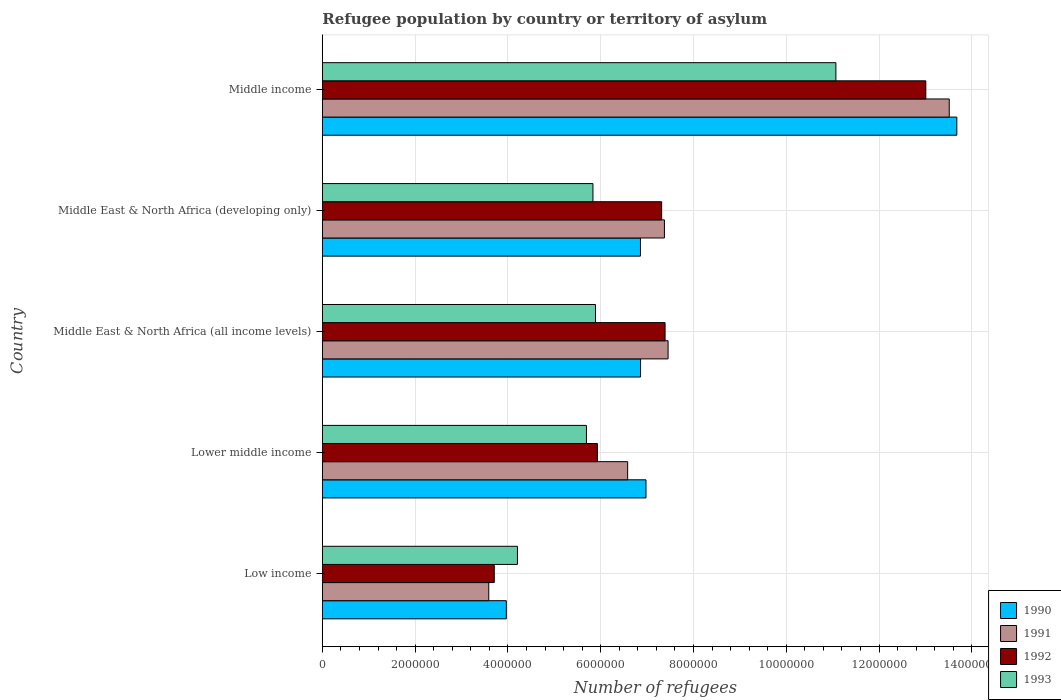How many different coloured bars are there?
Give a very brief answer. 4. How many groups of bars are there?
Keep it short and to the point. 5. Are the number of bars on each tick of the Y-axis equal?
Provide a succinct answer. Yes. How many bars are there on the 2nd tick from the top?
Give a very brief answer. 4. What is the label of the 5th group of bars from the top?
Offer a very short reply. Low income. In how many cases, is the number of bars for a given country not equal to the number of legend labels?
Provide a short and direct response. 0. What is the number of refugees in 1991 in Middle East & North Africa (developing only)?
Keep it short and to the point. 7.37e+06. Across all countries, what is the maximum number of refugees in 1993?
Your response must be concise. 1.11e+07. Across all countries, what is the minimum number of refugees in 1991?
Ensure brevity in your answer.  3.59e+06. What is the total number of refugees in 1990 in the graph?
Give a very brief answer. 3.83e+07. What is the difference between the number of refugees in 1991 in Middle East & North Africa (all income levels) and that in Middle income?
Provide a succinct answer. -6.06e+06. What is the difference between the number of refugees in 1992 in Middle East & North Africa (all income levels) and the number of refugees in 1991 in Lower middle income?
Offer a very short reply. 8.06e+05. What is the average number of refugees in 1991 per country?
Offer a very short reply. 7.70e+06. What is the difference between the number of refugees in 1990 and number of refugees in 1992 in Low income?
Your answer should be very brief. 2.60e+05. In how many countries, is the number of refugees in 1990 greater than 7600000 ?
Provide a succinct answer. 1. What is the ratio of the number of refugees in 1991 in Lower middle income to that in Middle East & North Africa (all income levels)?
Provide a succinct answer. 0.88. Is the difference between the number of refugees in 1990 in Low income and Middle income greater than the difference between the number of refugees in 1992 in Low income and Middle income?
Offer a very short reply. No. What is the difference between the highest and the second highest number of refugees in 1991?
Keep it short and to the point. 6.06e+06. What is the difference between the highest and the lowest number of refugees in 1991?
Offer a very short reply. 9.92e+06. Is the sum of the number of refugees in 1990 in Low income and Middle East & North Africa (developing only) greater than the maximum number of refugees in 1992 across all countries?
Offer a very short reply. No. What does the 4th bar from the bottom in Low income represents?
Provide a short and direct response. 1993. Is it the case that in every country, the sum of the number of refugees in 1993 and number of refugees in 1990 is greater than the number of refugees in 1992?
Provide a succinct answer. Yes. What is the difference between two consecutive major ticks on the X-axis?
Provide a short and direct response. 2.00e+06. Does the graph contain grids?
Offer a terse response. Yes. Where does the legend appear in the graph?
Your answer should be very brief. Bottom right. How are the legend labels stacked?
Give a very brief answer. Vertical. What is the title of the graph?
Keep it short and to the point. Refugee population by country or territory of asylum. Does "1987" appear as one of the legend labels in the graph?
Your answer should be very brief. No. What is the label or title of the X-axis?
Provide a short and direct response. Number of refugees. What is the Number of refugees of 1990 in Low income?
Ensure brevity in your answer.  3.97e+06. What is the Number of refugees in 1991 in Low income?
Ensure brevity in your answer.  3.59e+06. What is the Number of refugees of 1992 in Low income?
Offer a very short reply. 3.71e+06. What is the Number of refugees in 1993 in Low income?
Offer a terse response. 4.21e+06. What is the Number of refugees of 1990 in Lower middle income?
Keep it short and to the point. 6.98e+06. What is the Number of refugees of 1991 in Lower middle income?
Give a very brief answer. 6.58e+06. What is the Number of refugees in 1992 in Lower middle income?
Your answer should be compact. 5.93e+06. What is the Number of refugees in 1993 in Lower middle income?
Make the answer very short. 5.69e+06. What is the Number of refugees of 1990 in Middle East & North Africa (all income levels)?
Offer a terse response. 6.86e+06. What is the Number of refugees in 1991 in Middle East & North Africa (all income levels)?
Offer a terse response. 7.45e+06. What is the Number of refugees of 1992 in Middle East & North Africa (all income levels)?
Keep it short and to the point. 7.39e+06. What is the Number of refugees of 1993 in Middle East & North Africa (all income levels)?
Provide a succinct answer. 5.89e+06. What is the Number of refugees in 1990 in Middle East & North Africa (developing only)?
Provide a short and direct response. 6.86e+06. What is the Number of refugees in 1991 in Middle East & North Africa (developing only)?
Make the answer very short. 7.37e+06. What is the Number of refugees in 1992 in Middle East & North Africa (developing only)?
Your answer should be very brief. 7.31e+06. What is the Number of refugees in 1993 in Middle East & North Africa (developing only)?
Your answer should be very brief. 5.83e+06. What is the Number of refugees of 1990 in Middle income?
Ensure brevity in your answer.  1.37e+07. What is the Number of refugees of 1991 in Middle income?
Offer a terse response. 1.35e+07. What is the Number of refugees of 1992 in Middle income?
Ensure brevity in your answer.  1.30e+07. What is the Number of refugees of 1993 in Middle income?
Offer a very short reply. 1.11e+07. Across all countries, what is the maximum Number of refugees of 1990?
Your response must be concise. 1.37e+07. Across all countries, what is the maximum Number of refugees of 1991?
Ensure brevity in your answer.  1.35e+07. Across all countries, what is the maximum Number of refugees in 1992?
Offer a terse response. 1.30e+07. Across all countries, what is the maximum Number of refugees of 1993?
Your answer should be compact. 1.11e+07. Across all countries, what is the minimum Number of refugees of 1990?
Keep it short and to the point. 3.97e+06. Across all countries, what is the minimum Number of refugees in 1991?
Offer a very short reply. 3.59e+06. Across all countries, what is the minimum Number of refugees in 1992?
Ensure brevity in your answer.  3.71e+06. Across all countries, what is the minimum Number of refugees of 1993?
Provide a short and direct response. 4.21e+06. What is the total Number of refugees of 1990 in the graph?
Offer a terse response. 3.83e+07. What is the total Number of refugees of 1991 in the graph?
Keep it short and to the point. 3.85e+07. What is the total Number of refugees in 1992 in the graph?
Give a very brief answer. 3.73e+07. What is the total Number of refugees in 1993 in the graph?
Offer a very short reply. 3.27e+07. What is the difference between the Number of refugees in 1990 in Low income and that in Lower middle income?
Your answer should be compact. -3.01e+06. What is the difference between the Number of refugees in 1991 in Low income and that in Lower middle income?
Your response must be concise. -2.99e+06. What is the difference between the Number of refugees in 1992 in Low income and that in Lower middle income?
Make the answer very short. -2.22e+06. What is the difference between the Number of refugees of 1993 in Low income and that in Lower middle income?
Provide a succinct answer. -1.49e+06. What is the difference between the Number of refugees of 1990 in Low income and that in Middle East & North Africa (all income levels)?
Offer a very short reply. -2.89e+06. What is the difference between the Number of refugees in 1991 in Low income and that in Middle East & North Africa (all income levels)?
Make the answer very short. -3.86e+06. What is the difference between the Number of refugees of 1992 in Low income and that in Middle East & North Africa (all income levels)?
Ensure brevity in your answer.  -3.68e+06. What is the difference between the Number of refugees in 1993 in Low income and that in Middle East & North Africa (all income levels)?
Your answer should be very brief. -1.68e+06. What is the difference between the Number of refugees in 1990 in Low income and that in Middle East & North Africa (developing only)?
Offer a very short reply. -2.89e+06. What is the difference between the Number of refugees in 1991 in Low income and that in Middle East & North Africa (developing only)?
Keep it short and to the point. -3.79e+06. What is the difference between the Number of refugees in 1992 in Low income and that in Middle East & North Africa (developing only)?
Your answer should be compact. -3.61e+06. What is the difference between the Number of refugees in 1993 in Low income and that in Middle East & North Africa (developing only)?
Make the answer very short. -1.63e+06. What is the difference between the Number of refugees of 1990 in Low income and that in Middle income?
Make the answer very short. -9.71e+06. What is the difference between the Number of refugees in 1991 in Low income and that in Middle income?
Keep it short and to the point. -9.92e+06. What is the difference between the Number of refugees of 1992 in Low income and that in Middle income?
Make the answer very short. -9.30e+06. What is the difference between the Number of refugees in 1993 in Low income and that in Middle income?
Offer a terse response. -6.86e+06. What is the difference between the Number of refugees of 1990 in Lower middle income and that in Middle East & North Africa (all income levels)?
Provide a short and direct response. 1.17e+05. What is the difference between the Number of refugees of 1991 in Lower middle income and that in Middle East & North Africa (all income levels)?
Provide a short and direct response. -8.71e+05. What is the difference between the Number of refugees of 1992 in Lower middle income and that in Middle East & North Africa (all income levels)?
Your answer should be compact. -1.46e+06. What is the difference between the Number of refugees in 1993 in Lower middle income and that in Middle East & North Africa (all income levels)?
Keep it short and to the point. -1.95e+05. What is the difference between the Number of refugees of 1990 in Lower middle income and that in Middle East & North Africa (developing only)?
Your answer should be compact. 1.19e+05. What is the difference between the Number of refugees in 1991 in Lower middle income and that in Middle East & North Africa (developing only)?
Make the answer very short. -7.92e+05. What is the difference between the Number of refugees in 1992 in Lower middle income and that in Middle East & North Africa (developing only)?
Keep it short and to the point. -1.39e+06. What is the difference between the Number of refugees of 1993 in Lower middle income and that in Middle East & North Africa (developing only)?
Your answer should be compact. -1.40e+05. What is the difference between the Number of refugees of 1990 in Lower middle income and that in Middle income?
Provide a succinct answer. -6.70e+06. What is the difference between the Number of refugees of 1991 in Lower middle income and that in Middle income?
Your answer should be compact. -6.93e+06. What is the difference between the Number of refugees of 1992 in Lower middle income and that in Middle income?
Your response must be concise. -7.08e+06. What is the difference between the Number of refugees of 1993 in Lower middle income and that in Middle income?
Provide a succinct answer. -5.38e+06. What is the difference between the Number of refugees in 1990 in Middle East & North Africa (all income levels) and that in Middle East & North Africa (developing only)?
Offer a terse response. 1780. What is the difference between the Number of refugees in 1991 in Middle East & North Africa (all income levels) and that in Middle East & North Africa (developing only)?
Make the answer very short. 7.89e+04. What is the difference between the Number of refugees of 1992 in Middle East & North Africa (all income levels) and that in Middle East & North Africa (developing only)?
Provide a short and direct response. 7.35e+04. What is the difference between the Number of refugees in 1993 in Middle East & North Africa (all income levels) and that in Middle East & North Africa (developing only)?
Provide a succinct answer. 5.50e+04. What is the difference between the Number of refugees in 1990 in Middle East & North Africa (all income levels) and that in Middle income?
Your answer should be compact. -6.82e+06. What is the difference between the Number of refugees in 1991 in Middle East & North Africa (all income levels) and that in Middle income?
Your answer should be very brief. -6.06e+06. What is the difference between the Number of refugees in 1992 in Middle East & North Africa (all income levels) and that in Middle income?
Give a very brief answer. -5.62e+06. What is the difference between the Number of refugees in 1993 in Middle East & North Africa (all income levels) and that in Middle income?
Offer a terse response. -5.18e+06. What is the difference between the Number of refugees of 1990 in Middle East & North Africa (developing only) and that in Middle income?
Give a very brief answer. -6.82e+06. What is the difference between the Number of refugees in 1991 in Middle East & North Africa (developing only) and that in Middle income?
Your answer should be very brief. -6.14e+06. What is the difference between the Number of refugees of 1992 in Middle East & North Africa (developing only) and that in Middle income?
Offer a very short reply. -5.69e+06. What is the difference between the Number of refugees of 1993 in Middle East & North Africa (developing only) and that in Middle income?
Provide a short and direct response. -5.24e+06. What is the difference between the Number of refugees in 1990 in Low income and the Number of refugees in 1991 in Lower middle income?
Your answer should be compact. -2.62e+06. What is the difference between the Number of refugees of 1990 in Low income and the Number of refugees of 1992 in Lower middle income?
Offer a terse response. -1.96e+06. What is the difference between the Number of refugees in 1990 in Low income and the Number of refugees in 1993 in Lower middle income?
Provide a short and direct response. -1.73e+06. What is the difference between the Number of refugees in 1991 in Low income and the Number of refugees in 1992 in Lower middle income?
Keep it short and to the point. -2.34e+06. What is the difference between the Number of refugees in 1991 in Low income and the Number of refugees in 1993 in Lower middle income?
Make the answer very short. -2.11e+06. What is the difference between the Number of refugees in 1992 in Low income and the Number of refugees in 1993 in Lower middle income?
Ensure brevity in your answer.  -1.99e+06. What is the difference between the Number of refugees in 1990 in Low income and the Number of refugees in 1991 in Middle East & North Africa (all income levels)?
Provide a short and direct response. -3.49e+06. What is the difference between the Number of refugees of 1990 in Low income and the Number of refugees of 1992 in Middle East & North Africa (all income levels)?
Give a very brief answer. -3.42e+06. What is the difference between the Number of refugees of 1990 in Low income and the Number of refugees of 1993 in Middle East & North Africa (all income levels)?
Your response must be concise. -1.92e+06. What is the difference between the Number of refugees of 1991 in Low income and the Number of refugees of 1992 in Middle East & North Africa (all income levels)?
Your answer should be compact. -3.80e+06. What is the difference between the Number of refugees in 1991 in Low income and the Number of refugees in 1993 in Middle East & North Africa (all income levels)?
Provide a short and direct response. -2.30e+06. What is the difference between the Number of refugees in 1992 in Low income and the Number of refugees in 1993 in Middle East & North Africa (all income levels)?
Your response must be concise. -2.18e+06. What is the difference between the Number of refugees in 1990 in Low income and the Number of refugees in 1991 in Middle East & North Africa (developing only)?
Ensure brevity in your answer.  -3.41e+06. What is the difference between the Number of refugees in 1990 in Low income and the Number of refugees in 1992 in Middle East & North Africa (developing only)?
Ensure brevity in your answer.  -3.35e+06. What is the difference between the Number of refugees of 1990 in Low income and the Number of refugees of 1993 in Middle East & North Africa (developing only)?
Provide a succinct answer. -1.87e+06. What is the difference between the Number of refugees in 1991 in Low income and the Number of refugees in 1992 in Middle East & North Africa (developing only)?
Your response must be concise. -3.73e+06. What is the difference between the Number of refugees in 1991 in Low income and the Number of refugees in 1993 in Middle East & North Africa (developing only)?
Keep it short and to the point. -2.25e+06. What is the difference between the Number of refugees of 1992 in Low income and the Number of refugees of 1993 in Middle East & North Africa (developing only)?
Give a very brief answer. -2.13e+06. What is the difference between the Number of refugees of 1990 in Low income and the Number of refugees of 1991 in Middle income?
Offer a very short reply. -9.55e+06. What is the difference between the Number of refugees of 1990 in Low income and the Number of refugees of 1992 in Middle income?
Your answer should be compact. -9.04e+06. What is the difference between the Number of refugees in 1990 in Low income and the Number of refugees in 1993 in Middle income?
Your response must be concise. -7.10e+06. What is the difference between the Number of refugees of 1991 in Low income and the Number of refugees of 1992 in Middle income?
Your answer should be very brief. -9.42e+06. What is the difference between the Number of refugees of 1991 in Low income and the Number of refugees of 1993 in Middle income?
Ensure brevity in your answer.  -7.48e+06. What is the difference between the Number of refugees of 1992 in Low income and the Number of refugees of 1993 in Middle income?
Your answer should be compact. -7.36e+06. What is the difference between the Number of refugees in 1990 in Lower middle income and the Number of refugees in 1991 in Middle East & North Africa (all income levels)?
Offer a very short reply. -4.76e+05. What is the difference between the Number of refugees of 1990 in Lower middle income and the Number of refugees of 1992 in Middle East & North Africa (all income levels)?
Your response must be concise. -4.11e+05. What is the difference between the Number of refugees of 1990 in Lower middle income and the Number of refugees of 1993 in Middle East & North Africa (all income levels)?
Offer a terse response. 1.09e+06. What is the difference between the Number of refugees of 1991 in Lower middle income and the Number of refugees of 1992 in Middle East & North Africa (all income levels)?
Your response must be concise. -8.06e+05. What is the difference between the Number of refugees in 1991 in Lower middle income and the Number of refugees in 1993 in Middle East & North Africa (all income levels)?
Provide a succinct answer. 6.93e+05. What is the difference between the Number of refugees in 1992 in Lower middle income and the Number of refugees in 1993 in Middle East & North Africa (all income levels)?
Keep it short and to the point. 4.07e+04. What is the difference between the Number of refugees in 1990 in Lower middle income and the Number of refugees in 1991 in Middle East & North Africa (developing only)?
Offer a terse response. -3.97e+05. What is the difference between the Number of refugees in 1990 in Lower middle income and the Number of refugees in 1992 in Middle East & North Africa (developing only)?
Ensure brevity in your answer.  -3.38e+05. What is the difference between the Number of refugees in 1990 in Lower middle income and the Number of refugees in 1993 in Middle East & North Africa (developing only)?
Your response must be concise. 1.14e+06. What is the difference between the Number of refugees in 1991 in Lower middle income and the Number of refugees in 1992 in Middle East & North Africa (developing only)?
Provide a short and direct response. -7.33e+05. What is the difference between the Number of refugees in 1991 in Lower middle income and the Number of refugees in 1993 in Middle East & North Africa (developing only)?
Make the answer very short. 7.48e+05. What is the difference between the Number of refugees in 1992 in Lower middle income and the Number of refugees in 1993 in Middle East & North Africa (developing only)?
Provide a short and direct response. 9.57e+04. What is the difference between the Number of refugees of 1990 in Lower middle income and the Number of refugees of 1991 in Middle income?
Ensure brevity in your answer.  -6.54e+06. What is the difference between the Number of refugees in 1990 in Lower middle income and the Number of refugees in 1992 in Middle income?
Provide a short and direct response. -6.03e+06. What is the difference between the Number of refugees of 1990 in Lower middle income and the Number of refugees of 1993 in Middle income?
Give a very brief answer. -4.09e+06. What is the difference between the Number of refugees in 1991 in Lower middle income and the Number of refugees in 1992 in Middle income?
Offer a very short reply. -6.43e+06. What is the difference between the Number of refugees in 1991 in Lower middle income and the Number of refugees in 1993 in Middle income?
Make the answer very short. -4.49e+06. What is the difference between the Number of refugees of 1992 in Lower middle income and the Number of refugees of 1993 in Middle income?
Ensure brevity in your answer.  -5.14e+06. What is the difference between the Number of refugees in 1990 in Middle East & North Africa (all income levels) and the Number of refugees in 1991 in Middle East & North Africa (developing only)?
Offer a terse response. -5.14e+05. What is the difference between the Number of refugees of 1990 in Middle East & North Africa (all income levels) and the Number of refugees of 1992 in Middle East & North Africa (developing only)?
Provide a succinct answer. -4.55e+05. What is the difference between the Number of refugees of 1990 in Middle East & North Africa (all income levels) and the Number of refugees of 1993 in Middle East & North Africa (developing only)?
Your answer should be very brief. 1.03e+06. What is the difference between the Number of refugees of 1991 in Middle East & North Africa (all income levels) and the Number of refugees of 1992 in Middle East & North Africa (developing only)?
Ensure brevity in your answer.  1.38e+05. What is the difference between the Number of refugees of 1991 in Middle East & North Africa (all income levels) and the Number of refugees of 1993 in Middle East & North Africa (developing only)?
Keep it short and to the point. 1.62e+06. What is the difference between the Number of refugees of 1992 in Middle East & North Africa (all income levels) and the Number of refugees of 1993 in Middle East & North Africa (developing only)?
Your response must be concise. 1.55e+06. What is the difference between the Number of refugees of 1990 in Middle East & North Africa (all income levels) and the Number of refugees of 1991 in Middle income?
Provide a succinct answer. -6.65e+06. What is the difference between the Number of refugees in 1990 in Middle East & North Africa (all income levels) and the Number of refugees in 1992 in Middle income?
Your answer should be very brief. -6.15e+06. What is the difference between the Number of refugees of 1990 in Middle East & North Africa (all income levels) and the Number of refugees of 1993 in Middle income?
Your response must be concise. -4.21e+06. What is the difference between the Number of refugees of 1991 in Middle East & North Africa (all income levels) and the Number of refugees of 1992 in Middle income?
Provide a short and direct response. -5.55e+06. What is the difference between the Number of refugees of 1991 in Middle East & North Africa (all income levels) and the Number of refugees of 1993 in Middle income?
Give a very brief answer. -3.62e+06. What is the difference between the Number of refugees in 1992 in Middle East & North Africa (all income levels) and the Number of refugees in 1993 in Middle income?
Make the answer very short. -3.68e+06. What is the difference between the Number of refugees in 1990 in Middle East & North Africa (developing only) and the Number of refugees in 1991 in Middle income?
Offer a very short reply. -6.66e+06. What is the difference between the Number of refugees of 1990 in Middle East & North Africa (developing only) and the Number of refugees of 1992 in Middle income?
Your response must be concise. -6.15e+06. What is the difference between the Number of refugees of 1990 in Middle East & North Africa (developing only) and the Number of refugees of 1993 in Middle income?
Keep it short and to the point. -4.21e+06. What is the difference between the Number of refugees in 1991 in Middle East & North Africa (developing only) and the Number of refugees in 1992 in Middle income?
Ensure brevity in your answer.  -5.63e+06. What is the difference between the Number of refugees of 1991 in Middle East & North Africa (developing only) and the Number of refugees of 1993 in Middle income?
Your answer should be very brief. -3.70e+06. What is the difference between the Number of refugees in 1992 in Middle East & North Africa (developing only) and the Number of refugees in 1993 in Middle income?
Your response must be concise. -3.76e+06. What is the average Number of refugees in 1990 per country?
Your answer should be very brief. 7.67e+06. What is the average Number of refugees of 1991 per country?
Your answer should be compact. 7.70e+06. What is the average Number of refugees of 1992 per country?
Offer a terse response. 7.47e+06. What is the average Number of refugees in 1993 per country?
Keep it short and to the point. 6.54e+06. What is the difference between the Number of refugees of 1990 and Number of refugees of 1991 in Low income?
Keep it short and to the point. 3.78e+05. What is the difference between the Number of refugees in 1990 and Number of refugees in 1992 in Low income?
Provide a short and direct response. 2.60e+05. What is the difference between the Number of refugees of 1990 and Number of refugees of 1993 in Low income?
Offer a very short reply. -2.40e+05. What is the difference between the Number of refugees of 1991 and Number of refugees of 1992 in Low income?
Give a very brief answer. -1.19e+05. What is the difference between the Number of refugees in 1991 and Number of refugees in 1993 in Low income?
Keep it short and to the point. -6.18e+05. What is the difference between the Number of refugees of 1992 and Number of refugees of 1993 in Low income?
Provide a short and direct response. -5.00e+05. What is the difference between the Number of refugees of 1990 and Number of refugees of 1991 in Lower middle income?
Make the answer very short. 3.95e+05. What is the difference between the Number of refugees of 1990 and Number of refugees of 1992 in Lower middle income?
Your answer should be compact. 1.05e+06. What is the difference between the Number of refugees in 1990 and Number of refugees in 1993 in Lower middle income?
Make the answer very short. 1.28e+06. What is the difference between the Number of refugees of 1991 and Number of refugees of 1992 in Lower middle income?
Ensure brevity in your answer.  6.52e+05. What is the difference between the Number of refugees of 1991 and Number of refugees of 1993 in Lower middle income?
Keep it short and to the point. 8.88e+05. What is the difference between the Number of refugees of 1992 and Number of refugees of 1993 in Lower middle income?
Offer a terse response. 2.36e+05. What is the difference between the Number of refugees in 1990 and Number of refugees in 1991 in Middle East & North Africa (all income levels)?
Provide a short and direct response. -5.93e+05. What is the difference between the Number of refugees of 1990 and Number of refugees of 1992 in Middle East & North Africa (all income levels)?
Offer a very short reply. -5.28e+05. What is the difference between the Number of refugees in 1990 and Number of refugees in 1993 in Middle East & North Africa (all income levels)?
Provide a succinct answer. 9.71e+05. What is the difference between the Number of refugees in 1991 and Number of refugees in 1992 in Middle East & North Africa (all income levels)?
Provide a short and direct response. 6.48e+04. What is the difference between the Number of refugees in 1991 and Number of refugees in 1993 in Middle East & North Africa (all income levels)?
Your response must be concise. 1.56e+06. What is the difference between the Number of refugees of 1992 and Number of refugees of 1993 in Middle East & North Africa (all income levels)?
Your answer should be very brief. 1.50e+06. What is the difference between the Number of refugees in 1990 and Number of refugees in 1991 in Middle East & North Africa (developing only)?
Your response must be concise. -5.16e+05. What is the difference between the Number of refugees in 1990 and Number of refugees in 1992 in Middle East & North Africa (developing only)?
Make the answer very short. -4.57e+05. What is the difference between the Number of refugees in 1990 and Number of refugees in 1993 in Middle East & North Africa (developing only)?
Your answer should be very brief. 1.02e+06. What is the difference between the Number of refugees in 1991 and Number of refugees in 1992 in Middle East & North Africa (developing only)?
Offer a very short reply. 5.95e+04. What is the difference between the Number of refugees in 1991 and Number of refugees in 1993 in Middle East & North Africa (developing only)?
Your answer should be compact. 1.54e+06. What is the difference between the Number of refugees of 1992 and Number of refugees of 1993 in Middle East & North Africa (developing only)?
Your answer should be compact. 1.48e+06. What is the difference between the Number of refugees of 1990 and Number of refugees of 1991 in Middle income?
Ensure brevity in your answer.  1.63e+05. What is the difference between the Number of refugees in 1990 and Number of refugees in 1992 in Middle income?
Provide a succinct answer. 6.69e+05. What is the difference between the Number of refugees in 1990 and Number of refugees in 1993 in Middle income?
Offer a very short reply. 2.61e+06. What is the difference between the Number of refugees in 1991 and Number of refugees in 1992 in Middle income?
Your answer should be very brief. 5.05e+05. What is the difference between the Number of refugees in 1991 and Number of refugees in 1993 in Middle income?
Make the answer very short. 2.44e+06. What is the difference between the Number of refugees of 1992 and Number of refugees of 1993 in Middle income?
Your answer should be very brief. 1.94e+06. What is the ratio of the Number of refugees in 1990 in Low income to that in Lower middle income?
Offer a terse response. 0.57. What is the ratio of the Number of refugees of 1991 in Low income to that in Lower middle income?
Offer a terse response. 0.55. What is the ratio of the Number of refugees of 1992 in Low income to that in Lower middle income?
Offer a very short reply. 0.63. What is the ratio of the Number of refugees in 1993 in Low income to that in Lower middle income?
Provide a short and direct response. 0.74. What is the ratio of the Number of refugees in 1990 in Low income to that in Middle East & North Africa (all income levels)?
Offer a very short reply. 0.58. What is the ratio of the Number of refugees in 1991 in Low income to that in Middle East & North Africa (all income levels)?
Your answer should be very brief. 0.48. What is the ratio of the Number of refugees in 1992 in Low income to that in Middle East & North Africa (all income levels)?
Provide a short and direct response. 0.5. What is the ratio of the Number of refugees of 1993 in Low income to that in Middle East & North Africa (all income levels)?
Keep it short and to the point. 0.71. What is the ratio of the Number of refugees of 1990 in Low income to that in Middle East & North Africa (developing only)?
Provide a succinct answer. 0.58. What is the ratio of the Number of refugees in 1991 in Low income to that in Middle East & North Africa (developing only)?
Give a very brief answer. 0.49. What is the ratio of the Number of refugees of 1992 in Low income to that in Middle East & North Africa (developing only)?
Offer a terse response. 0.51. What is the ratio of the Number of refugees of 1993 in Low income to that in Middle East & North Africa (developing only)?
Provide a succinct answer. 0.72. What is the ratio of the Number of refugees in 1990 in Low income to that in Middle income?
Your answer should be very brief. 0.29. What is the ratio of the Number of refugees in 1991 in Low income to that in Middle income?
Ensure brevity in your answer.  0.27. What is the ratio of the Number of refugees in 1992 in Low income to that in Middle income?
Keep it short and to the point. 0.28. What is the ratio of the Number of refugees of 1993 in Low income to that in Middle income?
Make the answer very short. 0.38. What is the ratio of the Number of refugees of 1990 in Lower middle income to that in Middle East & North Africa (all income levels)?
Offer a very short reply. 1.02. What is the ratio of the Number of refugees in 1991 in Lower middle income to that in Middle East & North Africa (all income levels)?
Ensure brevity in your answer.  0.88. What is the ratio of the Number of refugees of 1992 in Lower middle income to that in Middle East & North Africa (all income levels)?
Your answer should be very brief. 0.8. What is the ratio of the Number of refugees of 1993 in Lower middle income to that in Middle East & North Africa (all income levels)?
Provide a succinct answer. 0.97. What is the ratio of the Number of refugees in 1990 in Lower middle income to that in Middle East & North Africa (developing only)?
Your response must be concise. 1.02. What is the ratio of the Number of refugees in 1991 in Lower middle income to that in Middle East & North Africa (developing only)?
Your answer should be very brief. 0.89. What is the ratio of the Number of refugees in 1992 in Lower middle income to that in Middle East & North Africa (developing only)?
Your response must be concise. 0.81. What is the ratio of the Number of refugees in 1993 in Lower middle income to that in Middle East & North Africa (developing only)?
Keep it short and to the point. 0.98. What is the ratio of the Number of refugees in 1990 in Lower middle income to that in Middle income?
Your response must be concise. 0.51. What is the ratio of the Number of refugees in 1991 in Lower middle income to that in Middle income?
Provide a succinct answer. 0.49. What is the ratio of the Number of refugees in 1992 in Lower middle income to that in Middle income?
Provide a short and direct response. 0.46. What is the ratio of the Number of refugees of 1993 in Lower middle income to that in Middle income?
Your answer should be very brief. 0.51. What is the ratio of the Number of refugees of 1990 in Middle East & North Africa (all income levels) to that in Middle East & North Africa (developing only)?
Offer a very short reply. 1. What is the ratio of the Number of refugees of 1991 in Middle East & North Africa (all income levels) to that in Middle East & North Africa (developing only)?
Ensure brevity in your answer.  1.01. What is the ratio of the Number of refugees of 1993 in Middle East & North Africa (all income levels) to that in Middle East & North Africa (developing only)?
Your answer should be compact. 1.01. What is the ratio of the Number of refugees in 1990 in Middle East & North Africa (all income levels) to that in Middle income?
Your answer should be compact. 0.5. What is the ratio of the Number of refugees in 1991 in Middle East & North Africa (all income levels) to that in Middle income?
Keep it short and to the point. 0.55. What is the ratio of the Number of refugees in 1992 in Middle East & North Africa (all income levels) to that in Middle income?
Give a very brief answer. 0.57. What is the ratio of the Number of refugees of 1993 in Middle East & North Africa (all income levels) to that in Middle income?
Make the answer very short. 0.53. What is the ratio of the Number of refugees of 1990 in Middle East & North Africa (developing only) to that in Middle income?
Your answer should be compact. 0.5. What is the ratio of the Number of refugees in 1991 in Middle East & North Africa (developing only) to that in Middle income?
Provide a succinct answer. 0.55. What is the ratio of the Number of refugees in 1992 in Middle East & North Africa (developing only) to that in Middle income?
Ensure brevity in your answer.  0.56. What is the ratio of the Number of refugees of 1993 in Middle East & North Africa (developing only) to that in Middle income?
Provide a succinct answer. 0.53. What is the difference between the highest and the second highest Number of refugees in 1990?
Keep it short and to the point. 6.70e+06. What is the difference between the highest and the second highest Number of refugees in 1991?
Keep it short and to the point. 6.06e+06. What is the difference between the highest and the second highest Number of refugees of 1992?
Ensure brevity in your answer.  5.62e+06. What is the difference between the highest and the second highest Number of refugees of 1993?
Provide a succinct answer. 5.18e+06. What is the difference between the highest and the lowest Number of refugees of 1990?
Make the answer very short. 9.71e+06. What is the difference between the highest and the lowest Number of refugees of 1991?
Provide a succinct answer. 9.92e+06. What is the difference between the highest and the lowest Number of refugees of 1992?
Ensure brevity in your answer.  9.30e+06. What is the difference between the highest and the lowest Number of refugees of 1993?
Your answer should be very brief. 6.86e+06. 